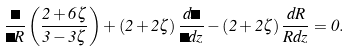<formula> <loc_0><loc_0><loc_500><loc_500>\frac { \Lambda } { \Gamma R } \left ( \frac { 2 + 6 \zeta } { 3 - 3 \zeta } \right ) + \left ( 2 + 2 \zeta \right ) \frac { d \Gamma } { \Gamma d z } - \left ( 2 + 2 \zeta \right ) \frac { d R } { R d z } = 0 .</formula> 